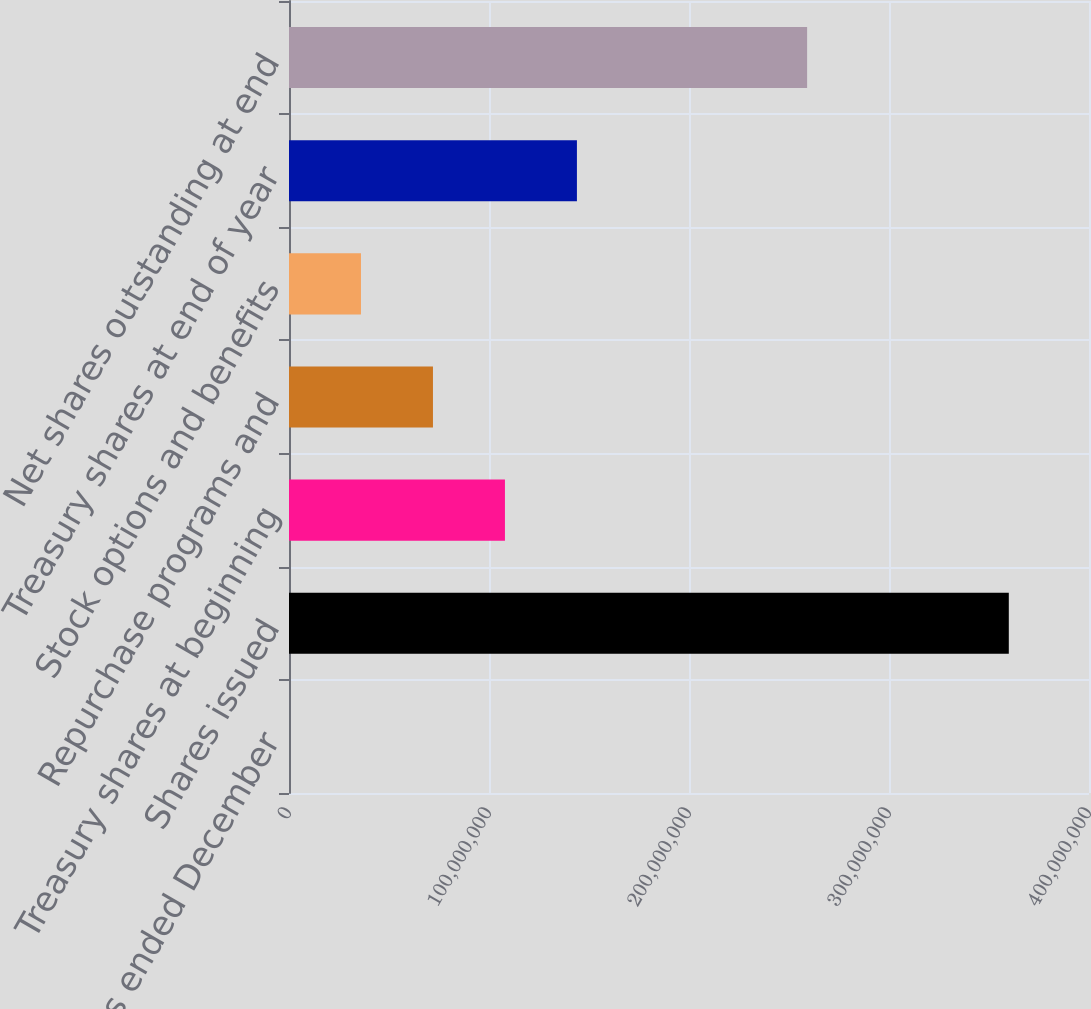Convert chart to OTSL. <chart><loc_0><loc_0><loc_500><loc_500><bar_chart><fcel>For the years ended December<fcel>Shares issued<fcel>Treasury shares at beginning<fcel>Repurchase programs and<fcel>Stock options and benefits<fcel>Treasury shares at end of year<fcel>Net shares outstanding at end<nl><fcel>2003<fcel>3.59902e+08<fcel>1.07972e+08<fcel>7.1982e+07<fcel>3.5992e+07<fcel>1.43962e+08<fcel>2.59059e+08<nl></chart> 